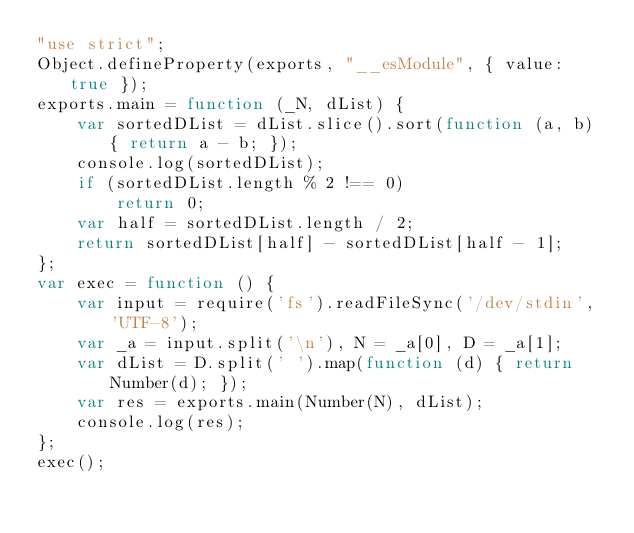<code> <loc_0><loc_0><loc_500><loc_500><_JavaScript_>"use strict";
Object.defineProperty(exports, "__esModule", { value: true });
exports.main = function (_N, dList) {
    var sortedDList = dList.slice().sort(function (a, b) { return a - b; });
    console.log(sortedDList);
    if (sortedDList.length % 2 !== 0)
        return 0;
    var half = sortedDList.length / 2;
    return sortedDList[half] - sortedDList[half - 1];
};
var exec = function () {
    var input = require('fs').readFileSync('/dev/stdin', 'UTF-8');
    var _a = input.split('\n'), N = _a[0], D = _a[1];
    var dList = D.split(' ').map(function (d) { return Number(d); });
    var res = exports.main(Number(N), dList);
    console.log(res);
};
exec();
</code> 